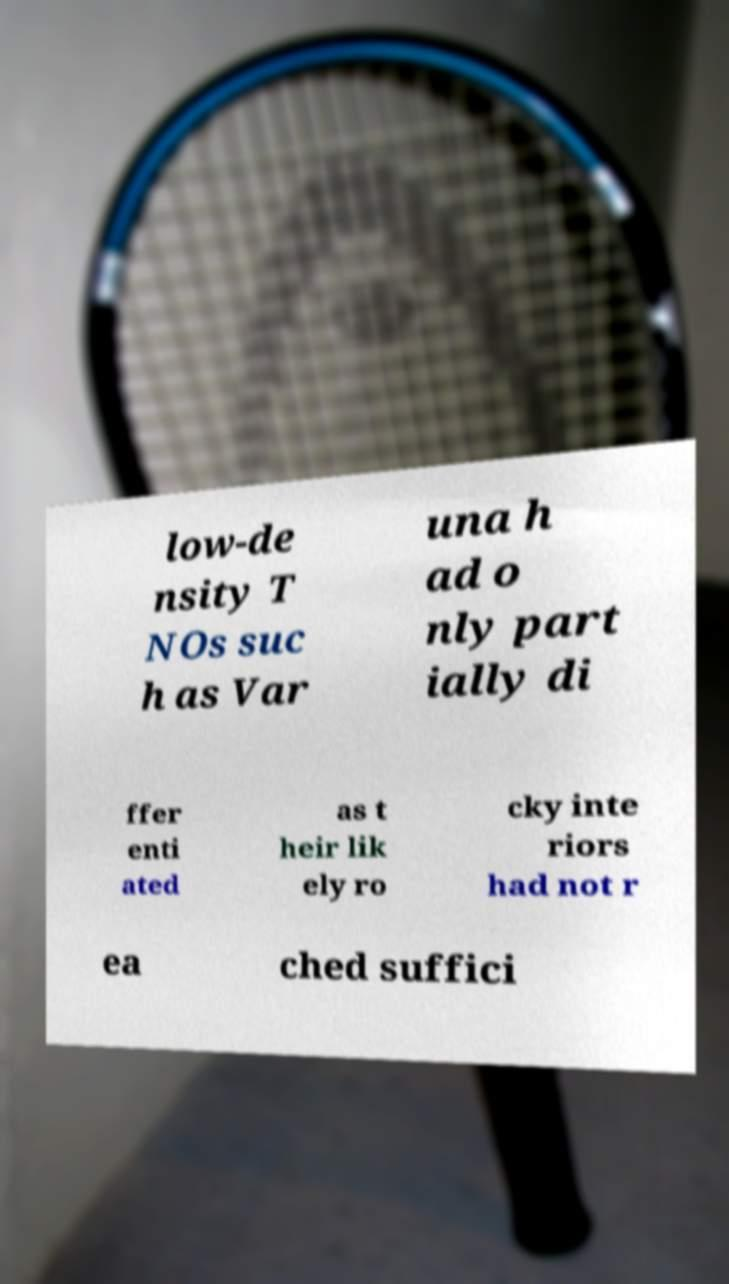What messages or text are displayed in this image? I need them in a readable, typed format. low-de nsity T NOs suc h as Var una h ad o nly part ially di ffer enti ated as t heir lik ely ro cky inte riors had not r ea ched suffici 